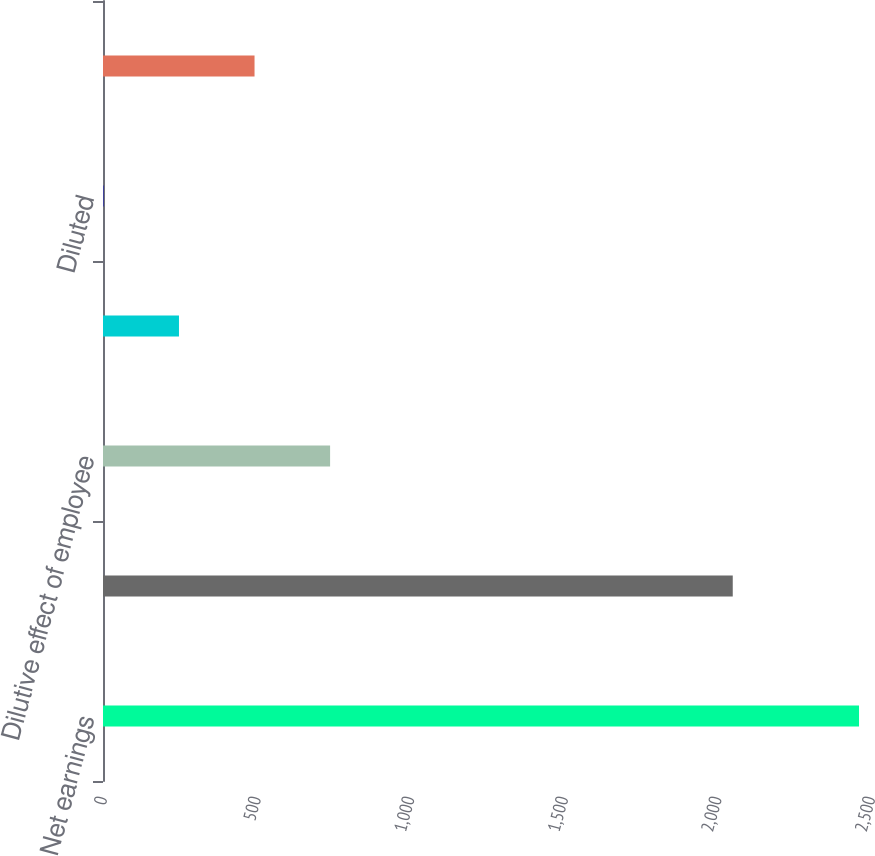Convert chart. <chart><loc_0><loc_0><loc_500><loc_500><bar_chart><fcel>Net earnings<fcel>Weighted-average shares used<fcel>Dilutive effect of employee<fcel>Basic<fcel>Diluted<fcel>Anti-dilutive weighted-average<nl><fcel>2461<fcel>2049.97<fcel>739.25<fcel>247.31<fcel>1.34<fcel>493.28<nl></chart> 